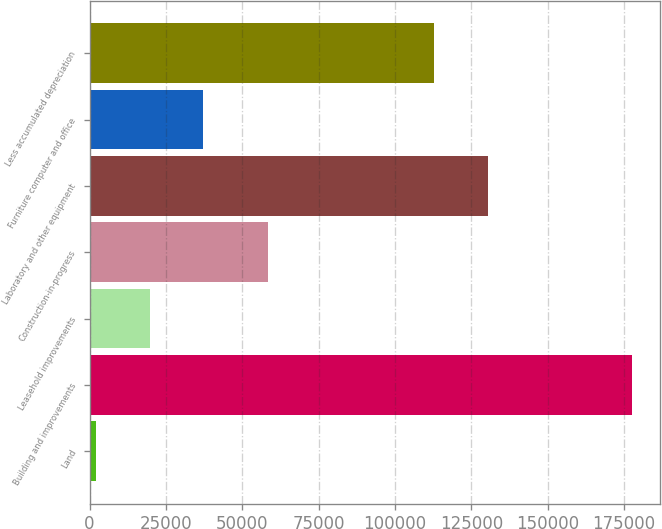Convert chart. <chart><loc_0><loc_0><loc_500><loc_500><bar_chart><fcel>Land<fcel>Building and improvements<fcel>Leasehold improvements<fcel>Construction-in-progress<fcel>Laboratory and other equipment<fcel>Furniture computer and office<fcel>Less accumulated depreciation<nl><fcel>2117<fcel>177710<fcel>19676.3<fcel>58541<fcel>130337<fcel>37235.6<fcel>112778<nl></chart> 